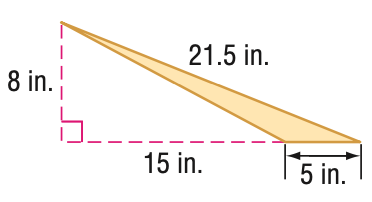Answer the mathemtical geometry problem and directly provide the correct option letter.
Question: Find the area of the triangle. Round to the nearest tenth if necessary.
Choices: A: 20 B: 40 C: 60 D: 80 A 